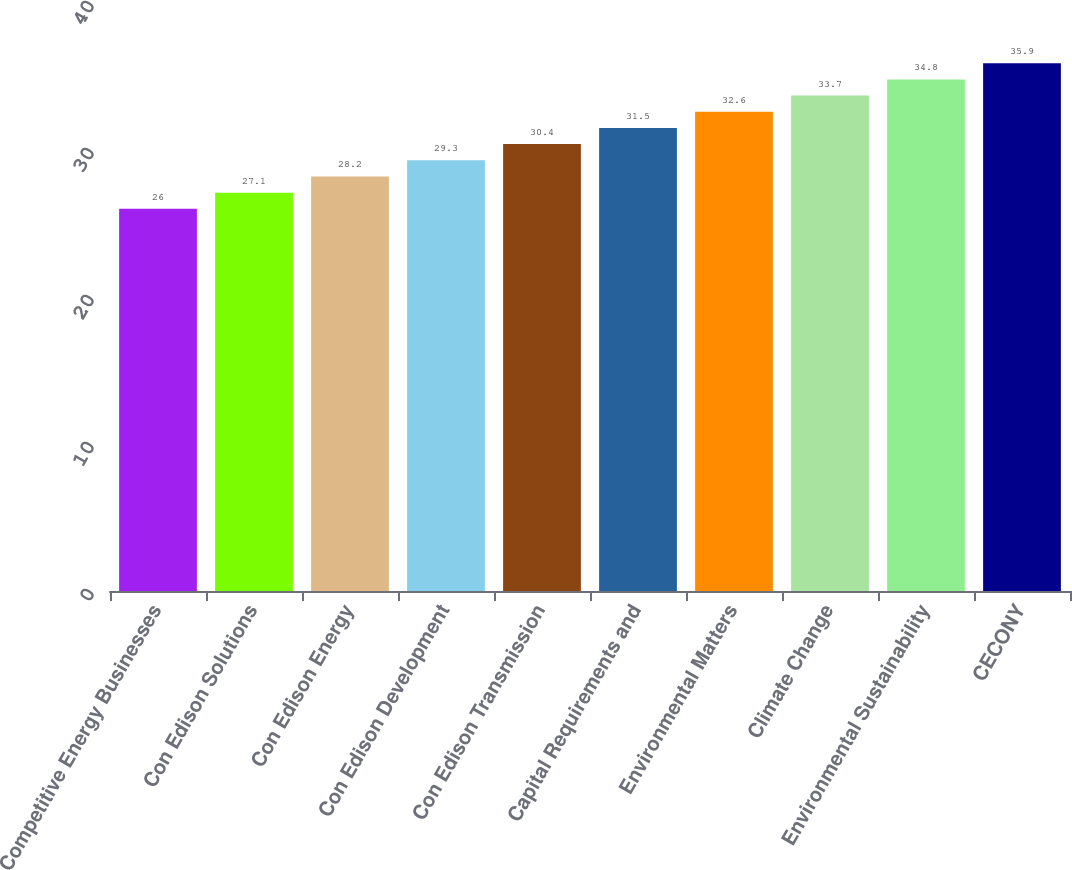<chart> <loc_0><loc_0><loc_500><loc_500><bar_chart><fcel>Competitive Energy Businesses<fcel>Con Edison Solutions<fcel>Con Edison Energy<fcel>Con Edison Development<fcel>Con Edison Transmission<fcel>Capital Requirements and<fcel>Environmental Matters<fcel>Climate Change<fcel>Environmental Sustainability<fcel>CECONY<nl><fcel>26<fcel>27.1<fcel>28.2<fcel>29.3<fcel>30.4<fcel>31.5<fcel>32.6<fcel>33.7<fcel>34.8<fcel>35.9<nl></chart> 